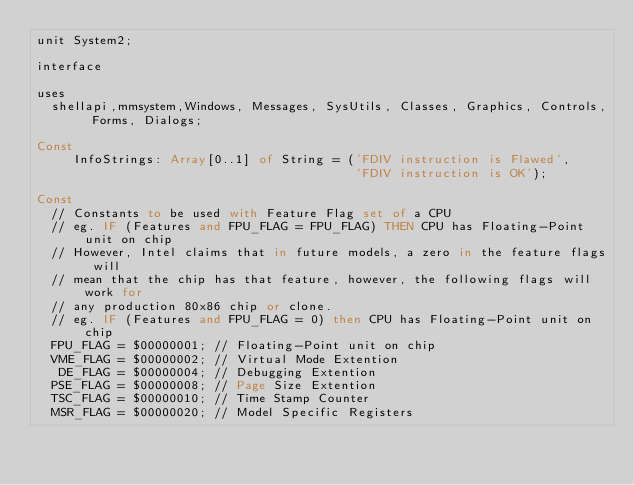<code> <loc_0><loc_0><loc_500><loc_500><_Pascal_>unit System2;

interface

uses
  shellapi,mmsystem,Windows, Messages, SysUtils, Classes, Graphics, Controls, Forms, Dialogs;

Const
     InfoStrings: Array[0..1] of String = ('FDIV instruction is Flawed',
                                           'FDIV instruction is OK');

Const
  // Constants to be used with Feature Flag set of a CPU
  // eg. IF (Features and FPU_FLAG = FPU_FLAG) THEN CPU has Floating-Point unit on chip
  // However, Intel claims that in future models, a zero in the feature flags will
  // mean that the chip has that feature, however, the following flags will work for
  // any production 80x86 chip or clone.
  // eg. IF (Features and FPU_FLAG = 0) then CPU has Floating-Point unit on chip
  FPU_FLAG = $00000001; // Floating-Point unit on chip
  VME_FLAG = $00000002; // Virtual Mode Extention
   DE_FLAG = $00000004; // Debugging Extention
  PSE_FLAG = $00000008; // Page Size Extention
  TSC_FLAG = $00000010; // Time Stamp Counter
  MSR_FLAG = $00000020; // Model Specific Registers</code> 